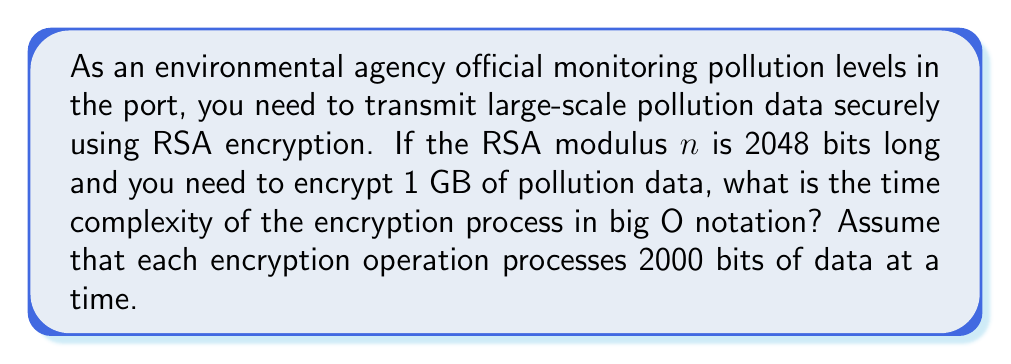Can you solve this math problem? To evaluate the computational complexity of RSA encryption for large-scale pollution monitoring data transmission, we need to consider the following steps:

1. Data size:
   1 GB = $1 \times 2^{30}$ bytes = $8 \times 2^{30}$ bits

2. Number of encryption operations:
   Each operation processes 2000 bits, so the number of operations is:
   $$\text{Number of operations} = \frac{8 \times 2^{30}}{2000} = 2^{21} \times 4$$

3. RSA encryption complexity:
   The time complexity of a single RSA encryption operation is $O(k^3)$, where $k$ is the number of bits in the modulus. In this case, $k = 2048$.

4. Total time complexity:
   The total time complexity is the product of the number of operations and the complexity of each operation:
   $$O(\text{Number of operations} \times k^3)$$
   $$O((2^{21} \times 4) \times 2048^3)$$
   $$O(2^{21} \times 2^{33})$$
   $$O(2^{54})$$

Therefore, the time complexity of encrypting 1 GB of pollution data using RSA with a 2048-bit modulus is $O(2^{54})$.
Answer: $O(2^{54})$ 